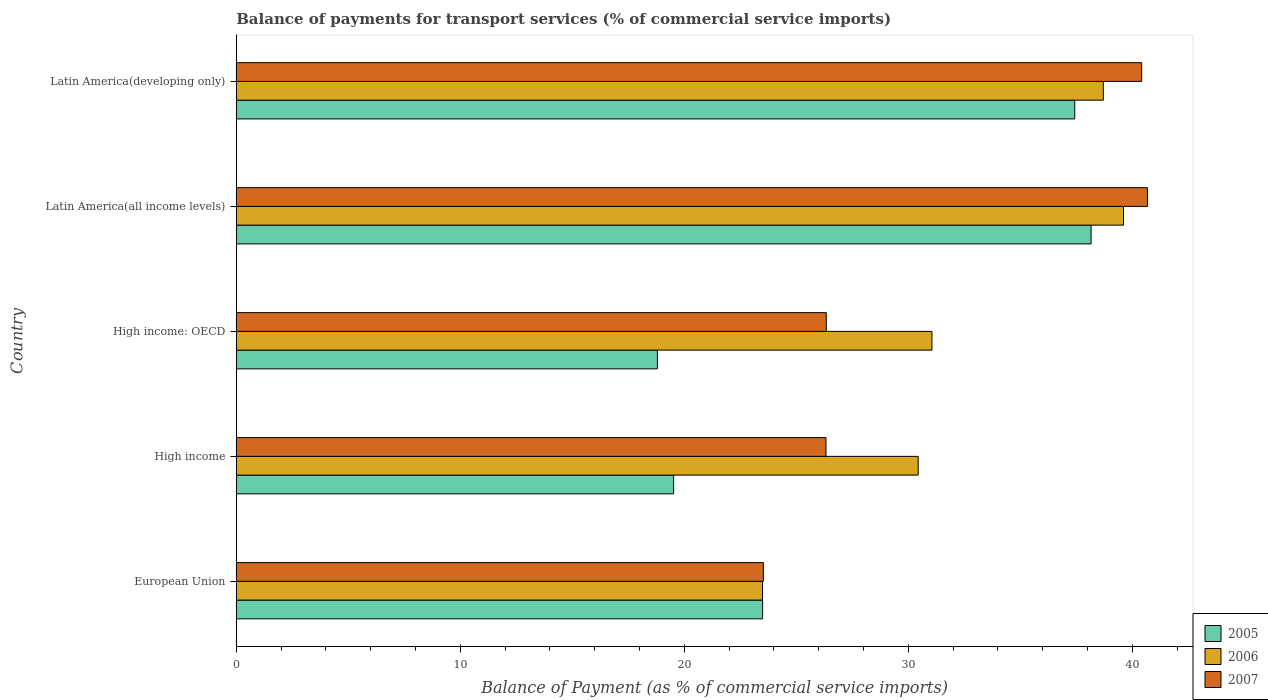How many different coloured bars are there?
Offer a very short reply. 3. How many groups of bars are there?
Offer a very short reply. 5. Are the number of bars on each tick of the Y-axis equal?
Your answer should be compact. Yes. What is the label of the 2nd group of bars from the top?
Offer a terse response. Latin America(all income levels). What is the balance of payments for transport services in 2007 in High income: OECD?
Offer a very short reply. 26.34. Across all countries, what is the maximum balance of payments for transport services in 2007?
Your answer should be very brief. 40.68. Across all countries, what is the minimum balance of payments for transport services in 2005?
Give a very brief answer. 18.8. In which country was the balance of payments for transport services in 2006 maximum?
Give a very brief answer. Latin America(all income levels). In which country was the balance of payments for transport services in 2005 minimum?
Offer a very short reply. High income: OECD. What is the total balance of payments for transport services in 2007 in the graph?
Your response must be concise. 157.3. What is the difference between the balance of payments for transport services in 2007 in High income: OECD and that in Latin America(all income levels)?
Provide a short and direct response. -14.34. What is the difference between the balance of payments for transport services in 2007 in High income and the balance of payments for transport services in 2006 in Latin America(developing only)?
Your answer should be very brief. -12.38. What is the average balance of payments for transport services in 2007 per country?
Keep it short and to the point. 31.46. What is the difference between the balance of payments for transport services in 2005 and balance of payments for transport services in 2007 in High income: OECD?
Provide a succinct answer. -7.54. In how many countries, is the balance of payments for transport services in 2005 greater than 6 %?
Keep it short and to the point. 5. What is the ratio of the balance of payments for transport services in 2005 in Latin America(all income levels) to that in Latin America(developing only)?
Provide a short and direct response. 1.02. Is the balance of payments for transport services in 2007 in European Union less than that in Latin America(all income levels)?
Ensure brevity in your answer.  Yes. Is the difference between the balance of payments for transport services in 2005 in High income and High income: OECD greater than the difference between the balance of payments for transport services in 2007 in High income and High income: OECD?
Give a very brief answer. Yes. What is the difference between the highest and the second highest balance of payments for transport services in 2006?
Make the answer very short. 0.9. What is the difference between the highest and the lowest balance of payments for transport services in 2005?
Your answer should be compact. 19.36. What does the 1st bar from the bottom in High income represents?
Give a very brief answer. 2005. How many countries are there in the graph?
Offer a terse response. 5. What is the difference between two consecutive major ticks on the X-axis?
Offer a terse response. 10. Are the values on the major ticks of X-axis written in scientific E-notation?
Your response must be concise. No. Does the graph contain grids?
Ensure brevity in your answer.  No. Where does the legend appear in the graph?
Provide a succinct answer. Bottom right. What is the title of the graph?
Your answer should be compact. Balance of payments for transport services (% of commercial service imports). Does "1989" appear as one of the legend labels in the graph?
Provide a short and direct response. No. What is the label or title of the X-axis?
Provide a succinct answer. Balance of Payment (as % of commercial service imports). What is the Balance of Payment (as % of commercial service imports) of 2005 in European Union?
Give a very brief answer. 23.5. What is the Balance of Payment (as % of commercial service imports) in 2006 in European Union?
Give a very brief answer. 23.5. What is the Balance of Payment (as % of commercial service imports) in 2007 in European Union?
Offer a terse response. 23.53. What is the Balance of Payment (as % of commercial service imports) in 2005 in High income?
Provide a succinct answer. 19.53. What is the Balance of Payment (as % of commercial service imports) in 2006 in High income?
Give a very brief answer. 30.44. What is the Balance of Payment (as % of commercial service imports) in 2007 in High income?
Offer a very short reply. 26.33. What is the Balance of Payment (as % of commercial service imports) in 2005 in High income: OECD?
Ensure brevity in your answer.  18.8. What is the Balance of Payment (as % of commercial service imports) in 2006 in High income: OECD?
Keep it short and to the point. 31.06. What is the Balance of Payment (as % of commercial service imports) of 2007 in High income: OECD?
Make the answer very short. 26.34. What is the Balance of Payment (as % of commercial service imports) in 2005 in Latin America(all income levels)?
Offer a terse response. 38.16. What is the Balance of Payment (as % of commercial service imports) of 2006 in Latin America(all income levels)?
Your response must be concise. 39.61. What is the Balance of Payment (as % of commercial service imports) in 2007 in Latin America(all income levels)?
Offer a very short reply. 40.68. What is the Balance of Payment (as % of commercial service imports) in 2005 in Latin America(developing only)?
Offer a terse response. 37.43. What is the Balance of Payment (as % of commercial service imports) in 2006 in Latin America(developing only)?
Give a very brief answer. 38.71. What is the Balance of Payment (as % of commercial service imports) in 2007 in Latin America(developing only)?
Make the answer very short. 40.42. Across all countries, what is the maximum Balance of Payment (as % of commercial service imports) of 2005?
Your response must be concise. 38.16. Across all countries, what is the maximum Balance of Payment (as % of commercial service imports) of 2006?
Make the answer very short. 39.61. Across all countries, what is the maximum Balance of Payment (as % of commercial service imports) of 2007?
Offer a very short reply. 40.68. Across all countries, what is the minimum Balance of Payment (as % of commercial service imports) in 2005?
Ensure brevity in your answer.  18.8. Across all countries, what is the minimum Balance of Payment (as % of commercial service imports) in 2006?
Make the answer very short. 23.5. Across all countries, what is the minimum Balance of Payment (as % of commercial service imports) in 2007?
Make the answer very short. 23.53. What is the total Balance of Payment (as % of commercial service imports) in 2005 in the graph?
Offer a terse response. 137.42. What is the total Balance of Payment (as % of commercial service imports) in 2006 in the graph?
Offer a terse response. 163.32. What is the total Balance of Payment (as % of commercial service imports) of 2007 in the graph?
Offer a terse response. 157.3. What is the difference between the Balance of Payment (as % of commercial service imports) of 2005 in European Union and that in High income?
Offer a very short reply. 3.97. What is the difference between the Balance of Payment (as % of commercial service imports) of 2006 in European Union and that in High income?
Your response must be concise. -6.95. What is the difference between the Balance of Payment (as % of commercial service imports) of 2007 in European Union and that in High income?
Provide a short and direct response. -2.8. What is the difference between the Balance of Payment (as % of commercial service imports) in 2005 in European Union and that in High income: OECD?
Ensure brevity in your answer.  4.7. What is the difference between the Balance of Payment (as % of commercial service imports) of 2006 in European Union and that in High income: OECD?
Your answer should be very brief. -7.56. What is the difference between the Balance of Payment (as % of commercial service imports) of 2007 in European Union and that in High income: OECD?
Offer a very short reply. -2.81. What is the difference between the Balance of Payment (as % of commercial service imports) of 2005 in European Union and that in Latin America(all income levels)?
Ensure brevity in your answer.  -14.66. What is the difference between the Balance of Payment (as % of commercial service imports) in 2006 in European Union and that in Latin America(all income levels)?
Keep it short and to the point. -16.11. What is the difference between the Balance of Payment (as % of commercial service imports) of 2007 in European Union and that in Latin America(all income levels)?
Your response must be concise. -17.15. What is the difference between the Balance of Payment (as % of commercial service imports) of 2005 in European Union and that in Latin America(developing only)?
Provide a succinct answer. -13.93. What is the difference between the Balance of Payment (as % of commercial service imports) in 2006 in European Union and that in Latin America(developing only)?
Offer a terse response. -15.21. What is the difference between the Balance of Payment (as % of commercial service imports) of 2007 in European Union and that in Latin America(developing only)?
Offer a very short reply. -16.89. What is the difference between the Balance of Payment (as % of commercial service imports) in 2005 in High income and that in High income: OECD?
Provide a short and direct response. 0.73. What is the difference between the Balance of Payment (as % of commercial service imports) of 2006 in High income and that in High income: OECD?
Give a very brief answer. -0.61. What is the difference between the Balance of Payment (as % of commercial service imports) in 2007 in High income and that in High income: OECD?
Provide a short and direct response. -0.01. What is the difference between the Balance of Payment (as % of commercial service imports) of 2005 in High income and that in Latin America(all income levels)?
Provide a short and direct response. -18.64. What is the difference between the Balance of Payment (as % of commercial service imports) of 2006 in High income and that in Latin America(all income levels)?
Provide a short and direct response. -9.17. What is the difference between the Balance of Payment (as % of commercial service imports) in 2007 in High income and that in Latin America(all income levels)?
Give a very brief answer. -14.35. What is the difference between the Balance of Payment (as % of commercial service imports) of 2005 in High income and that in Latin America(developing only)?
Offer a very short reply. -17.91. What is the difference between the Balance of Payment (as % of commercial service imports) in 2006 in High income and that in Latin America(developing only)?
Offer a very short reply. -8.27. What is the difference between the Balance of Payment (as % of commercial service imports) of 2007 in High income and that in Latin America(developing only)?
Your answer should be compact. -14.09. What is the difference between the Balance of Payment (as % of commercial service imports) of 2005 in High income: OECD and that in Latin America(all income levels)?
Your answer should be very brief. -19.36. What is the difference between the Balance of Payment (as % of commercial service imports) of 2006 in High income: OECD and that in Latin America(all income levels)?
Your response must be concise. -8.55. What is the difference between the Balance of Payment (as % of commercial service imports) of 2007 in High income: OECD and that in Latin America(all income levels)?
Provide a short and direct response. -14.34. What is the difference between the Balance of Payment (as % of commercial service imports) in 2005 in High income: OECD and that in Latin America(developing only)?
Your answer should be compact. -18.63. What is the difference between the Balance of Payment (as % of commercial service imports) of 2006 in High income: OECD and that in Latin America(developing only)?
Provide a succinct answer. -7.65. What is the difference between the Balance of Payment (as % of commercial service imports) in 2007 in High income: OECD and that in Latin America(developing only)?
Make the answer very short. -14.08. What is the difference between the Balance of Payment (as % of commercial service imports) of 2005 in Latin America(all income levels) and that in Latin America(developing only)?
Make the answer very short. 0.73. What is the difference between the Balance of Payment (as % of commercial service imports) in 2006 in Latin America(all income levels) and that in Latin America(developing only)?
Provide a succinct answer. 0.9. What is the difference between the Balance of Payment (as % of commercial service imports) of 2007 in Latin America(all income levels) and that in Latin America(developing only)?
Provide a succinct answer. 0.26. What is the difference between the Balance of Payment (as % of commercial service imports) in 2005 in European Union and the Balance of Payment (as % of commercial service imports) in 2006 in High income?
Your answer should be very brief. -6.94. What is the difference between the Balance of Payment (as % of commercial service imports) of 2005 in European Union and the Balance of Payment (as % of commercial service imports) of 2007 in High income?
Provide a succinct answer. -2.83. What is the difference between the Balance of Payment (as % of commercial service imports) in 2006 in European Union and the Balance of Payment (as % of commercial service imports) in 2007 in High income?
Your answer should be very brief. -2.83. What is the difference between the Balance of Payment (as % of commercial service imports) in 2005 in European Union and the Balance of Payment (as % of commercial service imports) in 2006 in High income: OECD?
Ensure brevity in your answer.  -7.56. What is the difference between the Balance of Payment (as % of commercial service imports) in 2005 in European Union and the Balance of Payment (as % of commercial service imports) in 2007 in High income: OECD?
Your answer should be compact. -2.84. What is the difference between the Balance of Payment (as % of commercial service imports) in 2006 in European Union and the Balance of Payment (as % of commercial service imports) in 2007 in High income: OECD?
Provide a succinct answer. -2.85. What is the difference between the Balance of Payment (as % of commercial service imports) in 2005 in European Union and the Balance of Payment (as % of commercial service imports) in 2006 in Latin America(all income levels)?
Provide a short and direct response. -16.11. What is the difference between the Balance of Payment (as % of commercial service imports) of 2005 in European Union and the Balance of Payment (as % of commercial service imports) of 2007 in Latin America(all income levels)?
Provide a succinct answer. -17.18. What is the difference between the Balance of Payment (as % of commercial service imports) of 2006 in European Union and the Balance of Payment (as % of commercial service imports) of 2007 in Latin America(all income levels)?
Keep it short and to the point. -17.18. What is the difference between the Balance of Payment (as % of commercial service imports) of 2005 in European Union and the Balance of Payment (as % of commercial service imports) of 2006 in Latin America(developing only)?
Your answer should be very brief. -15.21. What is the difference between the Balance of Payment (as % of commercial service imports) of 2005 in European Union and the Balance of Payment (as % of commercial service imports) of 2007 in Latin America(developing only)?
Give a very brief answer. -16.92. What is the difference between the Balance of Payment (as % of commercial service imports) in 2006 in European Union and the Balance of Payment (as % of commercial service imports) in 2007 in Latin America(developing only)?
Your answer should be very brief. -16.92. What is the difference between the Balance of Payment (as % of commercial service imports) in 2005 in High income and the Balance of Payment (as % of commercial service imports) in 2006 in High income: OECD?
Your answer should be compact. -11.53. What is the difference between the Balance of Payment (as % of commercial service imports) in 2005 in High income and the Balance of Payment (as % of commercial service imports) in 2007 in High income: OECD?
Your response must be concise. -6.81. What is the difference between the Balance of Payment (as % of commercial service imports) of 2006 in High income and the Balance of Payment (as % of commercial service imports) of 2007 in High income: OECD?
Offer a terse response. 4.1. What is the difference between the Balance of Payment (as % of commercial service imports) of 2005 in High income and the Balance of Payment (as % of commercial service imports) of 2006 in Latin America(all income levels)?
Your answer should be very brief. -20.08. What is the difference between the Balance of Payment (as % of commercial service imports) of 2005 in High income and the Balance of Payment (as % of commercial service imports) of 2007 in Latin America(all income levels)?
Keep it short and to the point. -21.15. What is the difference between the Balance of Payment (as % of commercial service imports) in 2006 in High income and the Balance of Payment (as % of commercial service imports) in 2007 in Latin America(all income levels)?
Give a very brief answer. -10.23. What is the difference between the Balance of Payment (as % of commercial service imports) of 2005 in High income and the Balance of Payment (as % of commercial service imports) of 2006 in Latin America(developing only)?
Ensure brevity in your answer.  -19.18. What is the difference between the Balance of Payment (as % of commercial service imports) in 2005 in High income and the Balance of Payment (as % of commercial service imports) in 2007 in Latin America(developing only)?
Provide a succinct answer. -20.89. What is the difference between the Balance of Payment (as % of commercial service imports) in 2006 in High income and the Balance of Payment (as % of commercial service imports) in 2007 in Latin America(developing only)?
Ensure brevity in your answer.  -9.98. What is the difference between the Balance of Payment (as % of commercial service imports) of 2005 in High income: OECD and the Balance of Payment (as % of commercial service imports) of 2006 in Latin America(all income levels)?
Ensure brevity in your answer.  -20.81. What is the difference between the Balance of Payment (as % of commercial service imports) in 2005 in High income: OECD and the Balance of Payment (as % of commercial service imports) in 2007 in Latin America(all income levels)?
Make the answer very short. -21.88. What is the difference between the Balance of Payment (as % of commercial service imports) of 2006 in High income: OECD and the Balance of Payment (as % of commercial service imports) of 2007 in Latin America(all income levels)?
Your response must be concise. -9.62. What is the difference between the Balance of Payment (as % of commercial service imports) in 2005 in High income: OECD and the Balance of Payment (as % of commercial service imports) in 2006 in Latin America(developing only)?
Provide a short and direct response. -19.91. What is the difference between the Balance of Payment (as % of commercial service imports) of 2005 in High income: OECD and the Balance of Payment (as % of commercial service imports) of 2007 in Latin America(developing only)?
Provide a succinct answer. -21.62. What is the difference between the Balance of Payment (as % of commercial service imports) in 2006 in High income: OECD and the Balance of Payment (as % of commercial service imports) in 2007 in Latin America(developing only)?
Your response must be concise. -9.36. What is the difference between the Balance of Payment (as % of commercial service imports) of 2005 in Latin America(all income levels) and the Balance of Payment (as % of commercial service imports) of 2006 in Latin America(developing only)?
Your answer should be very brief. -0.55. What is the difference between the Balance of Payment (as % of commercial service imports) of 2005 in Latin America(all income levels) and the Balance of Payment (as % of commercial service imports) of 2007 in Latin America(developing only)?
Offer a very short reply. -2.26. What is the difference between the Balance of Payment (as % of commercial service imports) of 2006 in Latin America(all income levels) and the Balance of Payment (as % of commercial service imports) of 2007 in Latin America(developing only)?
Offer a terse response. -0.81. What is the average Balance of Payment (as % of commercial service imports) of 2005 per country?
Ensure brevity in your answer.  27.48. What is the average Balance of Payment (as % of commercial service imports) in 2006 per country?
Offer a terse response. 32.66. What is the average Balance of Payment (as % of commercial service imports) in 2007 per country?
Your answer should be very brief. 31.46. What is the difference between the Balance of Payment (as % of commercial service imports) of 2005 and Balance of Payment (as % of commercial service imports) of 2006 in European Union?
Keep it short and to the point. 0. What is the difference between the Balance of Payment (as % of commercial service imports) of 2005 and Balance of Payment (as % of commercial service imports) of 2007 in European Union?
Give a very brief answer. -0.03. What is the difference between the Balance of Payment (as % of commercial service imports) in 2006 and Balance of Payment (as % of commercial service imports) in 2007 in European Union?
Ensure brevity in your answer.  -0.04. What is the difference between the Balance of Payment (as % of commercial service imports) in 2005 and Balance of Payment (as % of commercial service imports) in 2006 in High income?
Ensure brevity in your answer.  -10.92. What is the difference between the Balance of Payment (as % of commercial service imports) in 2005 and Balance of Payment (as % of commercial service imports) in 2007 in High income?
Make the answer very short. -6.8. What is the difference between the Balance of Payment (as % of commercial service imports) in 2006 and Balance of Payment (as % of commercial service imports) in 2007 in High income?
Offer a terse response. 4.12. What is the difference between the Balance of Payment (as % of commercial service imports) in 2005 and Balance of Payment (as % of commercial service imports) in 2006 in High income: OECD?
Your answer should be compact. -12.26. What is the difference between the Balance of Payment (as % of commercial service imports) of 2005 and Balance of Payment (as % of commercial service imports) of 2007 in High income: OECD?
Your answer should be compact. -7.54. What is the difference between the Balance of Payment (as % of commercial service imports) of 2006 and Balance of Payment (as % of commercial service imports) of 2007 in High income: OECD?
Ensure brevity in your answer.  4.72. What is the difference between the Balance of Payment (as % of commercial service imports) of 2005 and Balance of Payment (as % of commercial service imports) of 2006 in Latin America(all income levels)?
Keep it short and to the point. -1.45. What is the difference between the Balance of Payment (as % of commercial service imports) of 2005 and Balance of Payment (as % of commercial service imports) of 2007 in Latin America(all income levels)?
Ensure brevity in your answer.  -2.51. What is the difference between the Balance of Payment (as % of commercial service imports) in 2006 and Balance of Payment (as % of commercial service imports) in 2007 in Latin America(all income levels)?
Your answer should be very brief. -1.07. What is the difference between the Balance of Payment (as % of commercial service imports) of 2005 and Balance of Payment (as % of commercial service imports) of 2006 in Latin America(developing only)?
Ensure brevity in your answer.  -1.28. What is the difference between the Balance of Payment (as % of commercial service imports) of 2005 and Balance of Payment (as % of commercial service imports) of 2007 in Latin America(developing only)?
Offer a very short reply. -2.99. What is the difference between the Balance of Payment (as % of commercial service imports) in 2006 and Balance of Payment (as % of commercial service imports) in 2007 in Latin America(developing only)?
Your answer should be very brief. -1.71. What is the ratio of the Balance of Payment (as % of commercial service imports) in 2005 in European Union to that in High income?
Give a very brief answer. 1.2. What is the ratio of the Balance of Payment (as % of commercial service imports) of 2006 in European Union to that in High income?
Your answer should be compact. 0.77. What is the ratio of the Balance of Payment (as % of commercial service imports) of 2007 in European Union to that in High income?
Provide a succinct answer. 0.89. What is the ratio of the Balance of Payment (as % of commercial service imports) in 2005 in European Union to that in High income: OECD?
Keep it short and to the point. 1.25. What is the ratio of the Balance of Payment (as % of commercial service imports) of 2006 in European Union to that in High income: OECD?
Your answer should be very brief. 0.76. What is the ratio of the Balance of Payment (as % of commercial service imports) in 2007 in European Union to that in High income: OECD?
Provide a succinct answer. 0.89. What is the ratio of the Balance of Payment (as % of commercial service imports) in 2005 in European Union to that in Latin America(all income levels)?
Ensure brevity in your answer.  0.62. What is the ratio of the Balance of Payment (as % of commercial service imports) in 2006 in European Union to that in Latin America(all income levels)?
Provide a succinct answer. 0.59. What is the ratio of the Balance of Payment (as % of commercial service imports) of 2007 in European Union to that in Latin America(all income levels)?
Make the answer very short. 0.58. What is the ratio of the Balance of Payment (as % of commercial service imports) in 2005 in European Union to that in Latin America(developing only)?
Provide a succinct answer. 0.63. What is the ratio of the Balance of Payment (as % of commercial service imports) of 2006 in European Union to that in Latin America(developing only)?
Make the answer very short. 0.61. What is the ratio of the Balance of Payment (as % of commercial service imports) in 2007 in European Union to that in Latin America(developing only)?
Make the answer very short. 0.58. What is the ratio of the Balance of Payment (as % of commercial service imports) in 2005 in High income to that in High income: OECD?
Offer a very short reply. 1.04. What is the ratio of the Balance of Payment (as % of commercial service imports) of 2006 in High income to that in High income: OECD?
Your answer should be compact. 0.98. What is the ratio of the Balance of Payment (as % of commercial service imports) of 2007 in High income to that in High income: OECD?
Your response must be concise. 1. What is the ratio of the Balance of Payment (as % of commercial service imports) of 2005 in High income to that in Latin America(all income levels)?
Your answer should be compact. 0.51. What is the ratio of the Balance of Payment (as % of commercial service imports) of 2006 in High income to that in Latin America(all income levels)?
Provide a succinct answer. 0.77. What is the ratio of the Balance of Payment (as % of commercial service imports) in 2007 in High income to that in Latin America(all income levels)?
Ensure brevity in your answer.  0.65. What is the ratio of the Balance of Payment (as % of commercial service imports) of 2005 in High income to that in Latin America(developing only)?
Make the answer very short. 0.52. What is the ratio of the Balance of Payment (as % of commercial service imports) of 2006 in High income to that in Latin America(developing only)?
Your response must be concise. 0.79. What is the ratio of the Balance of Payment (as % of commercial service imports) in 2007 in High income to that in Latin America(developing only)?
Provide a succinct answer. 0.65. What is the ratio of the Balance of Payment (as % of commercial service imports) of 2005 in High income: OECD to that in Latin America(all income levels)?
Give a very brief answer. 0.49. What is the ratio of the Balance of Payment (as % of commercial service imports) in 2006 in High income: OECD to that in Latin America(all income levels)?
Your answer should be compact. 0.78. What is the ratio of the Balance of Payment (as % of commercial service imports) of 2007 in High income: OECD to that in Latin America(all income levels)?
Your answer should be compact. 0.65. What is the ratio of the Balance of Payment (as % of commercial service imports) in 2005 in High income: OECD to that in Latin America(developing only)?
Provide a succinct answer. 0.5. What is the ratio of the Balance of Payment (as % of commercial service imports) of 2006 in High income: OECD to that in Latin America(developing only)?
Your answer should be compact. 0.8. What is the ratio of the Balance of Payment (as % of commercial service imports) of 2007 in High income: OECD to that in Latin America(developing only)?
Offer a terse response. 0.65. What is the ratio of the Balance of Payment (as % of commercial service imports) in 2005 in Latin America(all income levels) to that in Latin America(developing only)?
Your answer should be very brief. 1.02. What is the ratio of the Balance of Payment (as % of commercial service imports) of 2006 in Latin America(all income levels) to that in Latin America(developing only)?
Keep it short and to the point. 1.02. What is the ratio of the Balance of Payment (as % of commercial service imports) in 2007 in Latin America(all income levels) to that in Latin America(developing only)?
Your answer should be very brief. 1.01. What is the difference between the highest and the second highest Balance of Payment (as % of commercial service imports) of 2005?
Offer a very short reply. 0.73. What is the difference between the highest and the second highest Balance of Payment (as % of commercial service imports) in 2006?
Provide a succinct answer. 0.9. What is the difference between the highest and the second highest Balance of Payment (as % of commercial service imports) of 2007?
Offer a very short reply. 0.26. What is the difference between the highest and the lowest Balance of Payment (as % of commercial service imports) in 2005?
Your answer should be very brief. 19.36. What is the difference between the highest and the lowest Balance of Payment (as % of commercial service imports) of 2006?
Make the answer very short. 16.11. What is the difference between the highest and the lowest Balance of Payment (as % of commercial service imports) in 2007?
Provide a succinct answer. 17.15. 